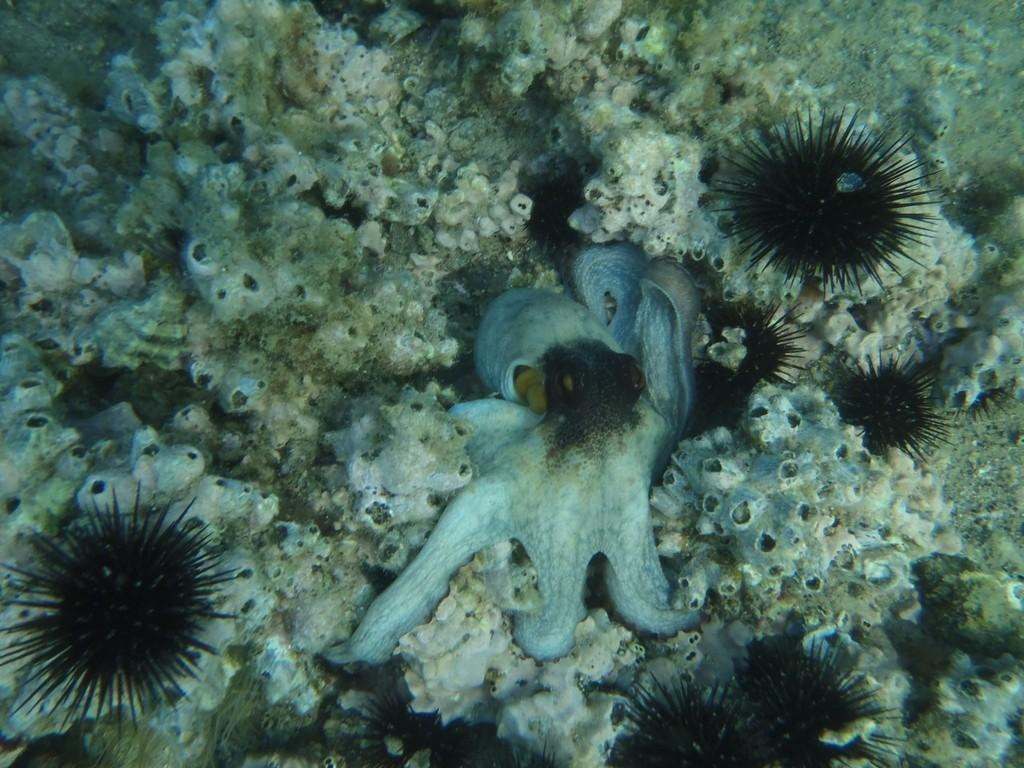What is the main subject of the image? There is an octopus in the image. Where is the octopus located? The octopus is in the water. Can you describe any other objects present in the image? Unfortunately, the provided facts do not specify any other objects present in the image. What is the name of the alley where the octopus is located? There is no alley present in the image, as the octopus is in the water. 